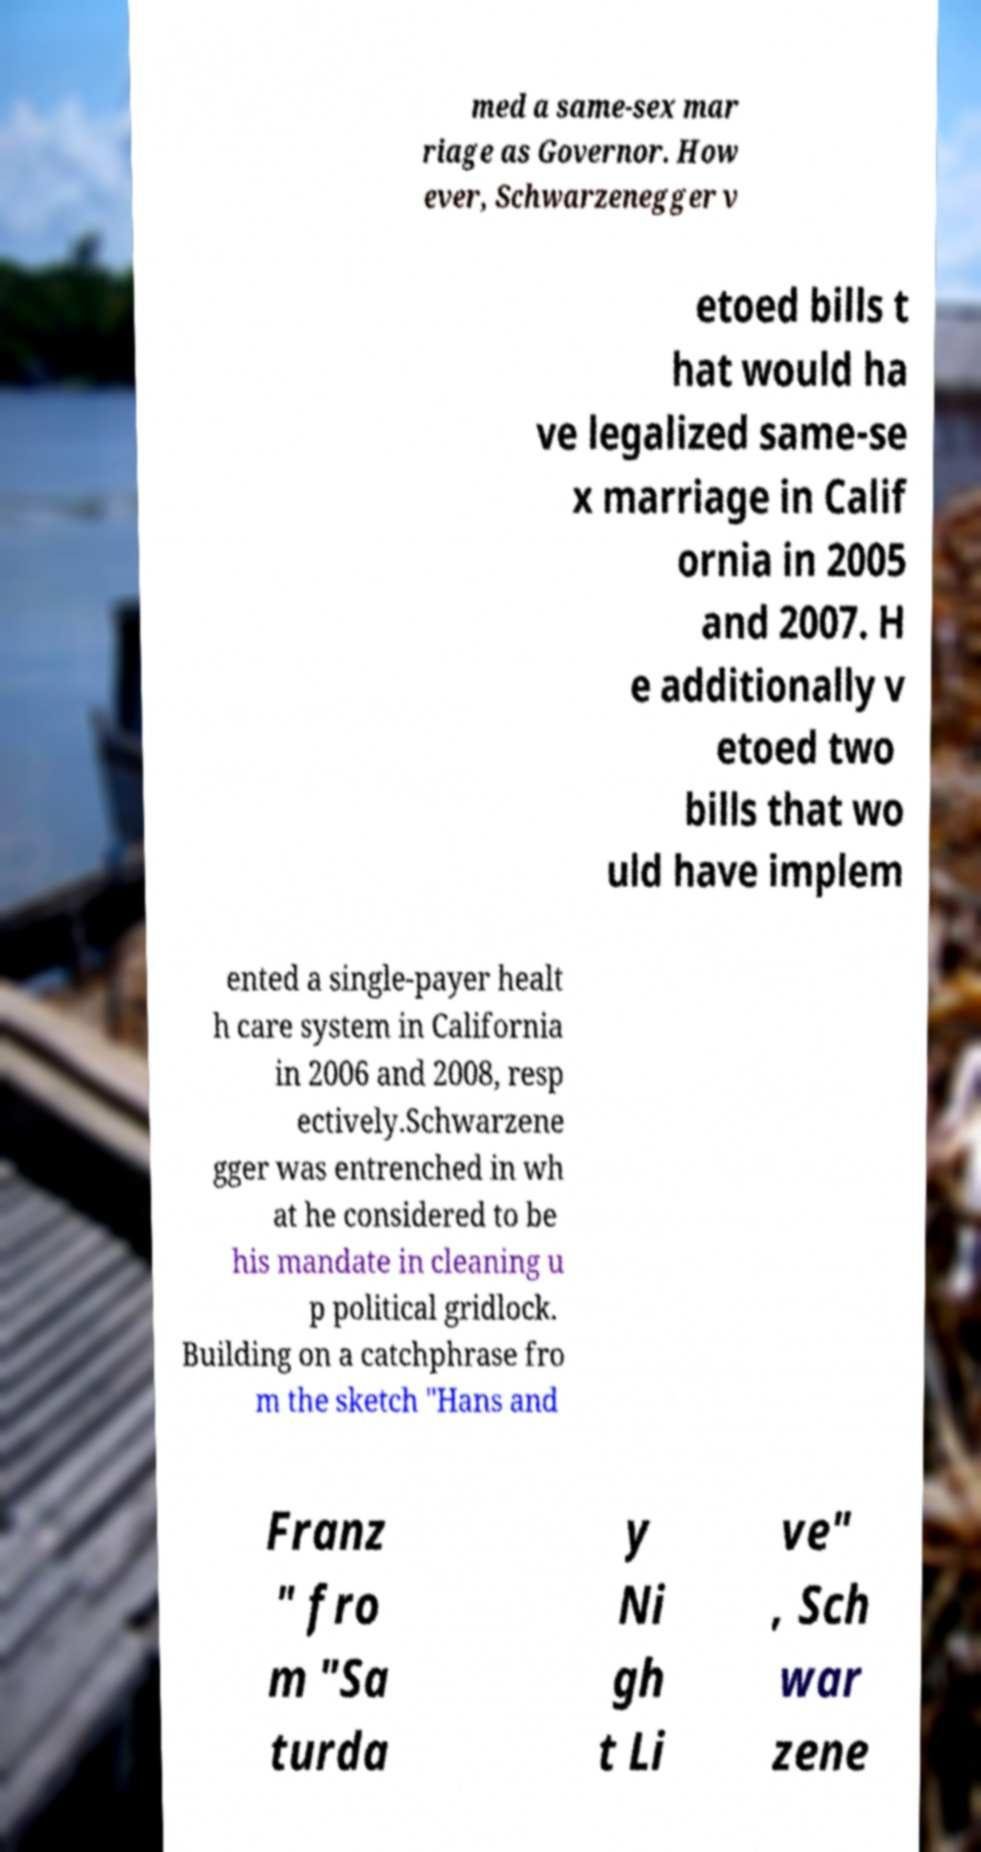What messages or text are displayed in this image? I need them in a readable, typed format. med a same-sex mar riage as Governor. How ever, Schwarzenegger v etoed bills t hat would ha ve legalized same-se x marriage in Calif ornia in 2005 and 2007. H e additionally v etoed two bills that wo uld have implem ented a single-payer healt h care system in California in 2006 and 2008, resp ectively.Schwarzene gger was entrenched in wh at he considered to be his mandate in cleaning u p political gridlock. Building on a catchphrase fro m the sketch "Hans and Franz " fro m "Sa turda y Ni gh t Li ve" , Sch war zene 